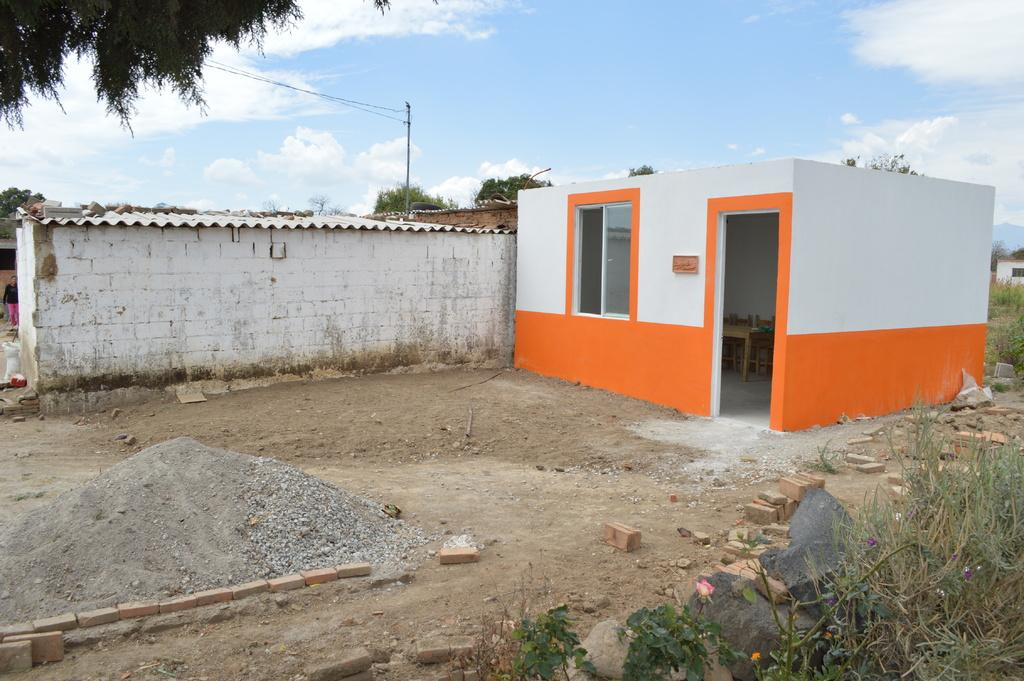What structure is located on the left side of the image? There is a shed on the left side of the image. What can be seen on the right side of the image? There is a room on the right side of the image. What type of natural element is at the top side of the image? There is a tree at the top side of the image. Is there an earthquake happening in the image? No, there is no indication of an earthquake in the image. Can you see any ducks in the image? No, there are no ducks present in the image. 